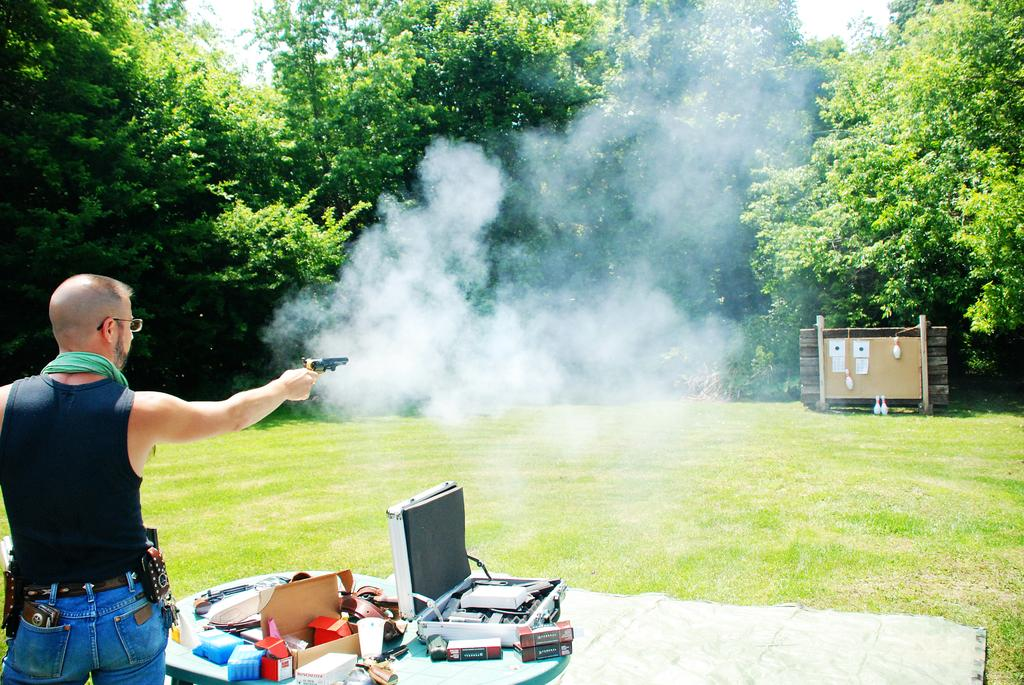What is the main subject of the image? There is a person in the image. What is the person holding in the image? The person is holding a gun. Where is the person standing in the image? The person is standing in front of a table. What can be seen on the table in the image? There are things on the table. What type of natural elements are present in the vicinity of the scene? There are trees and plants in the vicinity of the scene. What is the health status of the van in the image? There is no van present in the image, so it is not possible to determine its health status. 